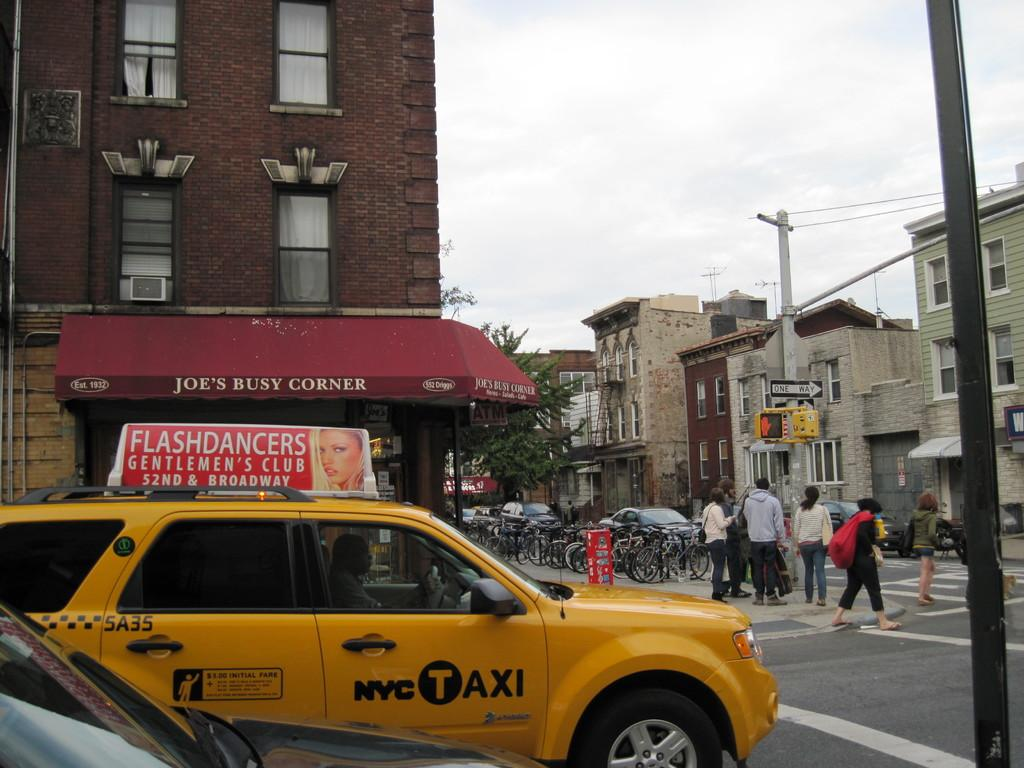<image>
Relay a brief, clear account of the picture shown. New york city taxi cab is parked near a car while walkers cross the road 